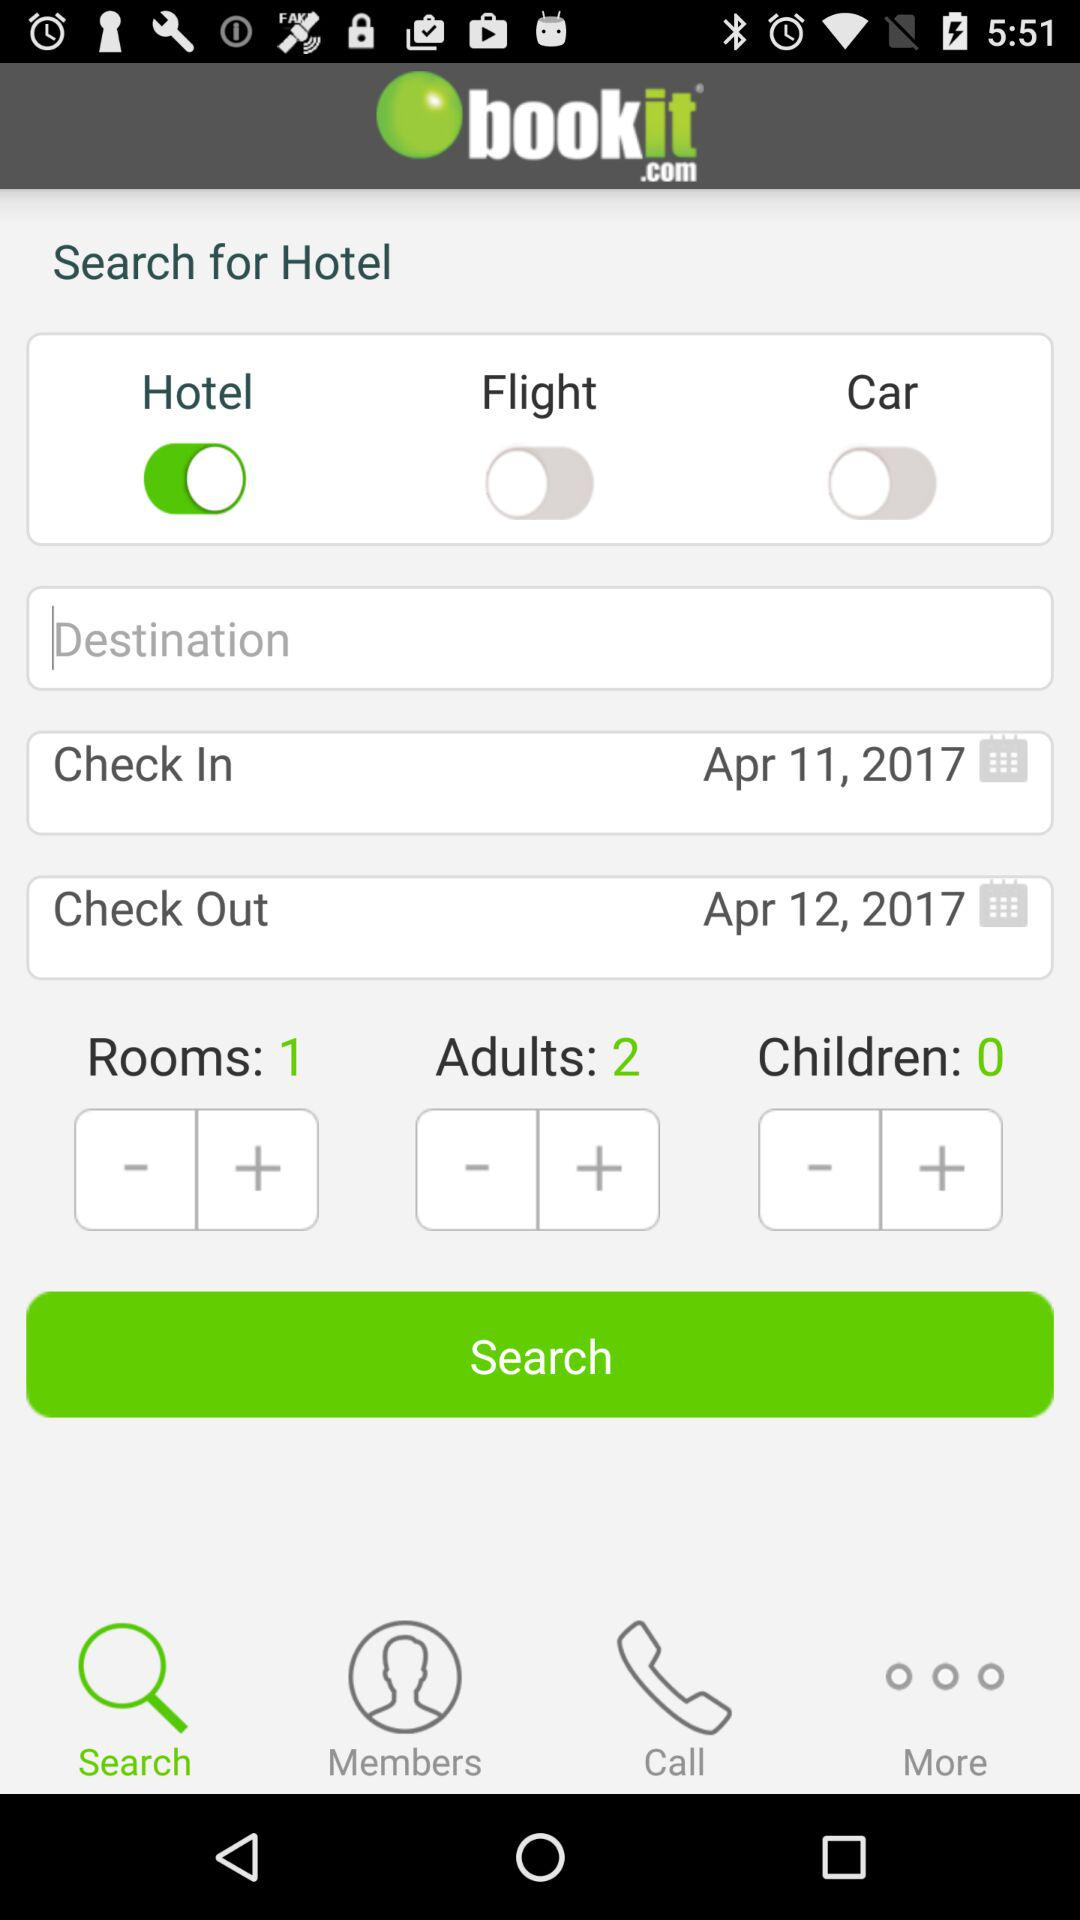What is the check-out date? The check-out date is April 12, 2017. 